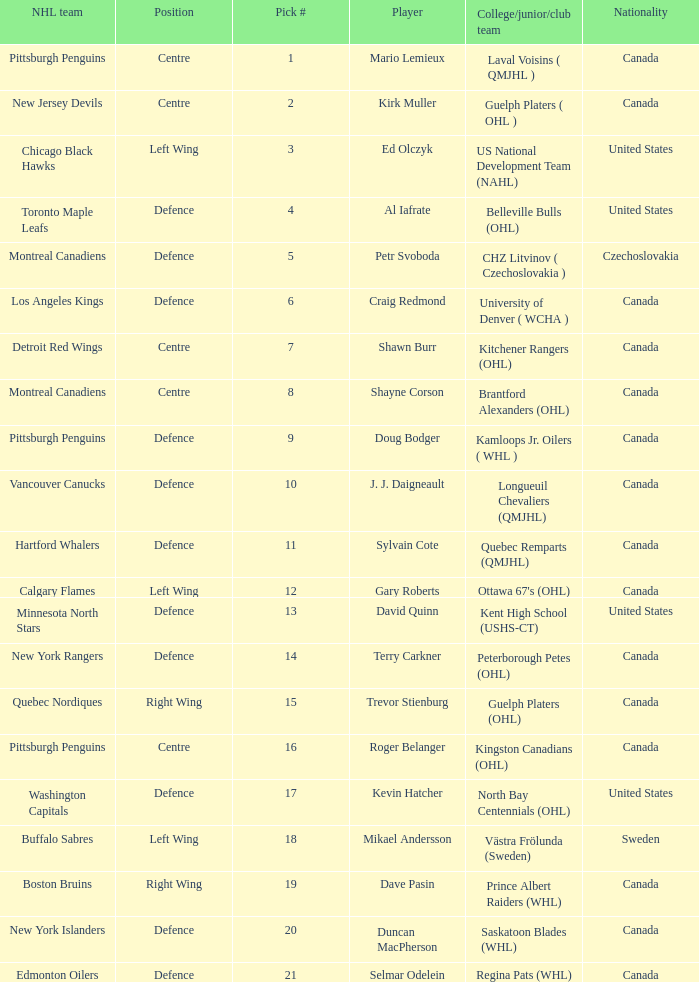Can you give me this table as a dict? {'header': ['NHL team', 'Position', 'Pick #', 'Player', 'College/junior/club team', 'Nationality'], 'rows': [['Pittsburgh Penguins', 'Centre', '1', 'Mario Lemieux', 'Laval Voisins ( QMJHL )', 'Canada'], ['New Jersey Devils', 'Centre', '2', 'Kirk Muller', 'Guelph Platers ( OHL )', 'Canada'], ['Chicago Black Hawks', 'Left Wing', '3', 'Ed Olczyk', 'US National Development Team (NAHL)', 'United States'], ['Toronto Maple Leafs', 'Defence', '4', 'Al Iafrate', 'Belleville Bulls (OHL)', 'United States'], ['Montreal Canadiens', 'Defence', '5', 'Petr Svoboda', 'CHZ Litvinov ( Czechoslovakia )', 'Czechoslovakia'], ['Los Angeles Kings', 'Defence', '6', 'Craig Redmond', 'University of Denver ( WCHA )', 'Canada'], ['Detroit Red Wings', 'Centre', '7', 'Shawn Burr', 'Kitchener Rangers (OHL)', 'Canada'], ['Montreal Canadiens', 'Centre', '8', 'Shayne Corson', 'Brantford Alexanders (OHL)', 'Canada'], ['Pittsburgh Penguins', 'Defence', '9', 'Doug Bodger', 'Kamloops Jr. Oilers ( WHL )', 'Canada'], ['Vancouver Canucks', 'Defence', '10', 'J. J. Daigneault', 'Longueuil Chevaliers (QMJHL)', 'Canada'], ['Hartford Whalers', 'Defence', '11', 'Sylvain Cote', 'Quebec Remparts (QMJHL)', 'Canada'], ['Calgary Flames', 'Left Wing', '12', 'Gary Roberts', "Ottawa 67's (OHL)", 'Canada'], ['Minnesota North Stars', 'Defence', '13', 'David Quinn', 'Kent High School (USHS-CT)', 'United States'], ['New York Rangers', 'Defence', '14', 'Terry Carkner', 'Peterborough Petes (OHL)', 'Canada'], ['Quebec Nordiques', 'Right Wing', '15', 'Trevor Stienburg', 'Guelph Platers (OHL)', 'Canada'], ['Pittsburgh Penguins', 'Centre', '16', 'Roger Belanger', 'Kingston Canadians (OHL)', 'Canada'], ['Washington Capitals', 'Defence', '17', 'Kevin Hatcher', 'North Bay Centennials (OHL)', 'United States'], ['Buffalo Sabres', 'Left Wing', '18', 'Mikael Andersson', 'Västra Frölunda (Sweden)', 'Sweden'], ['Boston Bruins', 'Right Wing', '19', 'Dave Pasin', 'Prince Albert Raiders (WHL)', 'Canada'], ['New York Islanders', 'Defence', '20', 'Duncan MacPherson', 'Saskatoon Blades (WHL)', 'Canada'], ['Edmonton Oilers', 'Defence', '21', 'Selmar Odelein', 'Regina Pats (WHL)', 'Canada']]} What player is draft pick 17? Kevin Hatcher. 